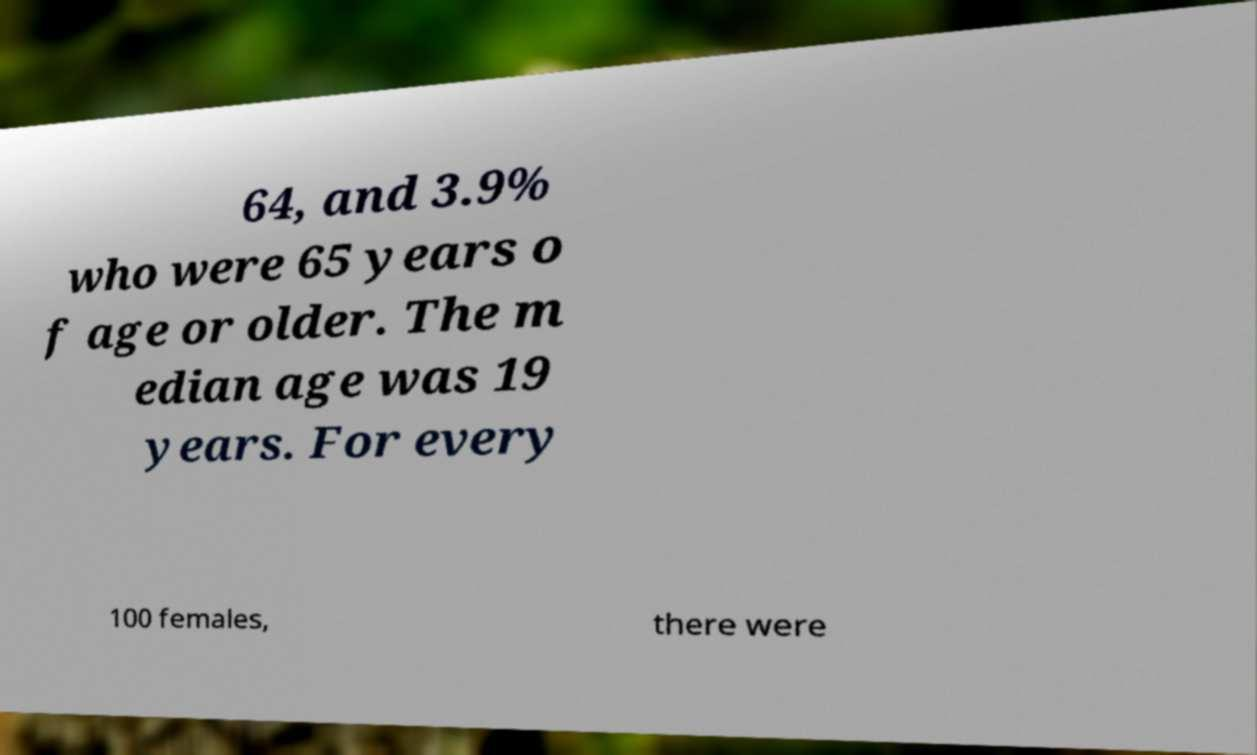Can you accurately transcribe the text from the provided image for me? 64, and 3.9% who were 65 years o f age or older. The m edian age was 19 years. For every 100 females, there were 